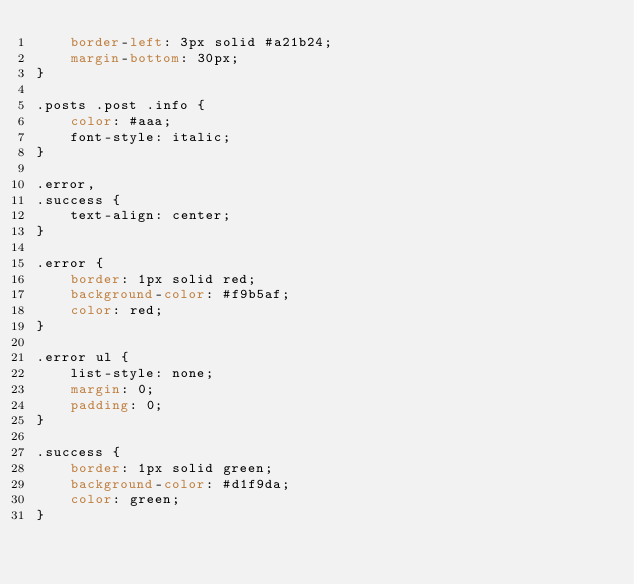<code> <loc_0><loc_0><loc_500><loc_500><_CSS_>    border-left: 3px solid #a21b24;
    margin-bottom: 30px;
}

.posts .post .info {
    color: #aaa;
    font-style: italic;
}

.error,
.success {
    text-align: center;
}

.error {
    border: 1px solid red;
    background-color: #f9b5af;
    color: red;
}

.error ul {
    list-style: none;
    margin: 0;
    padding: 0;
}

.success {
    border: 1px solid green;
    background-color: #d1f9da;
    color: green;
}</code> 